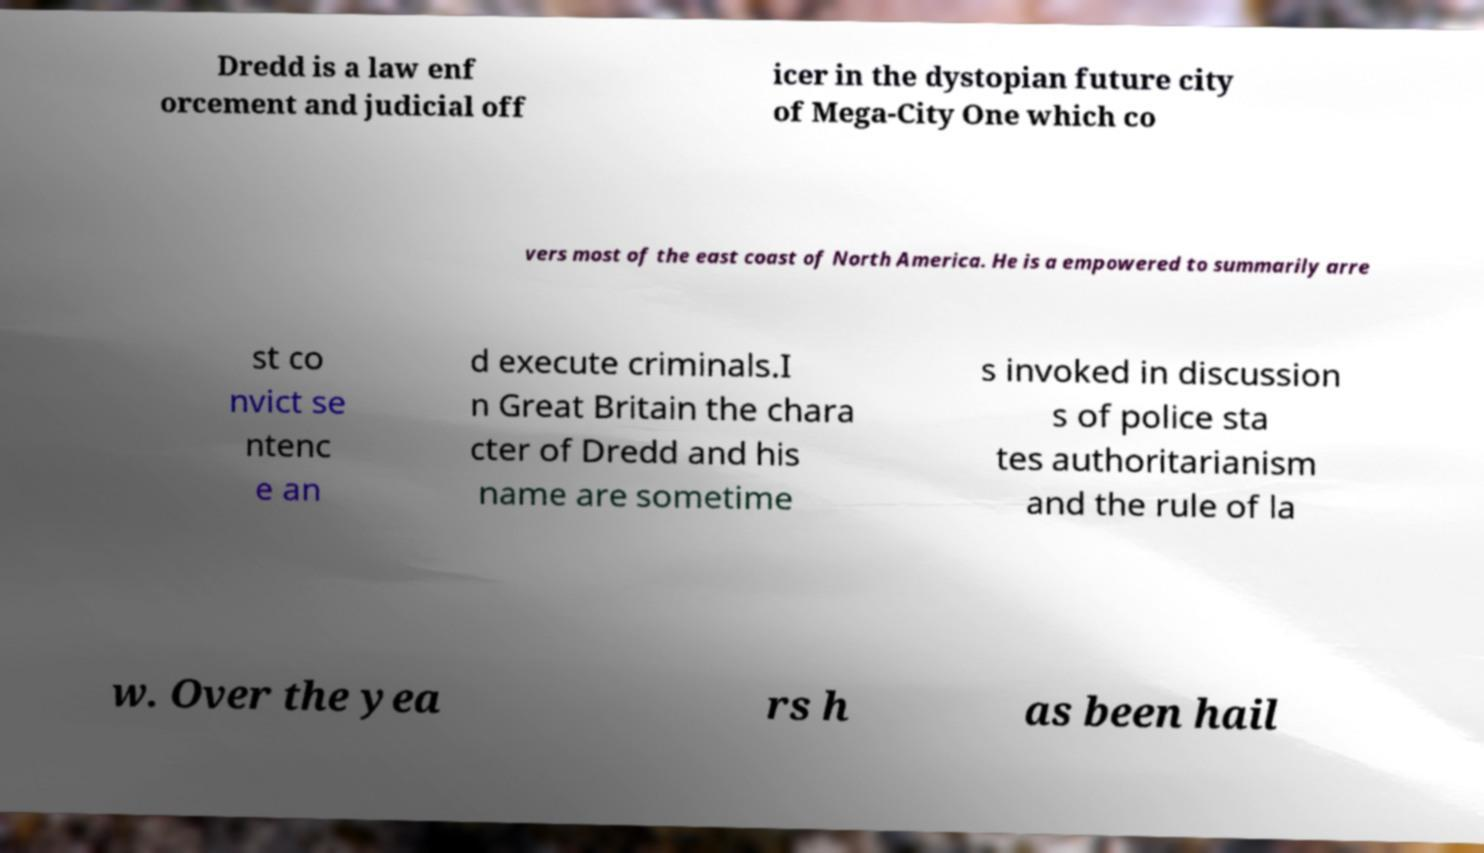Please read and relay the text visible in this image. What does it say? Dredd is a law enf orcement and judicial off icer in the dystopian future city of Mega-City One which co vers most of the east coast of North America. He is a empowered to summarily arre st co nvict se ntenc e an d execute criminals.I n Great Britain the chara cter of Dredd and his name are sometime s invoked in discussion s of police sta tes authoritarianism and the rule of la w. Over the yea rs h as been hail 